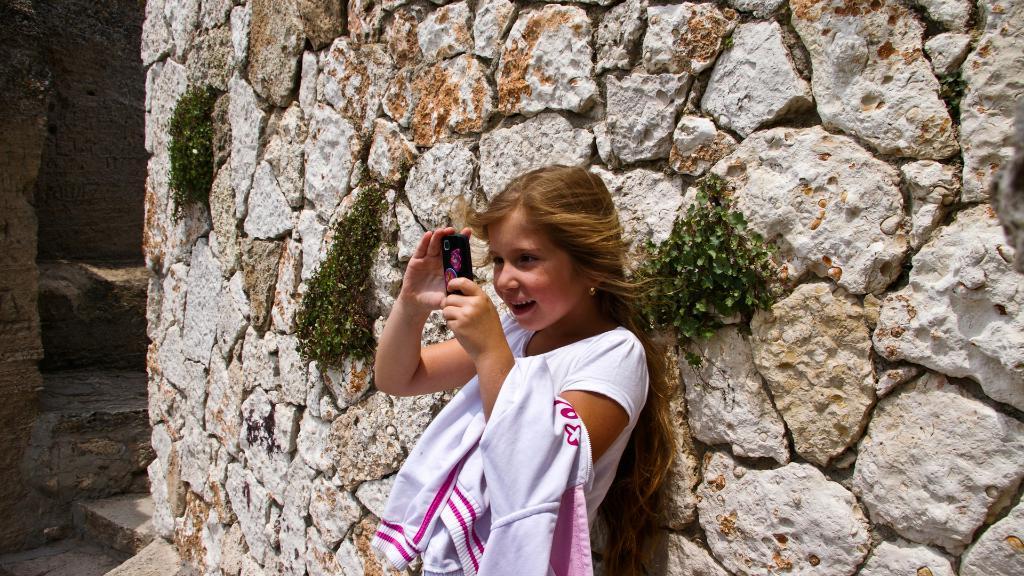In one or two sentences, can you explain what this image depicts? In this image we can see a girl. A girl is holding a mobile phone. There is rock wall and few plants attached to it. 